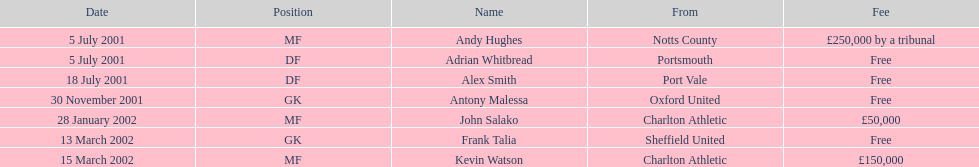How much did it cost to transfer kevin watson? £150,000. 